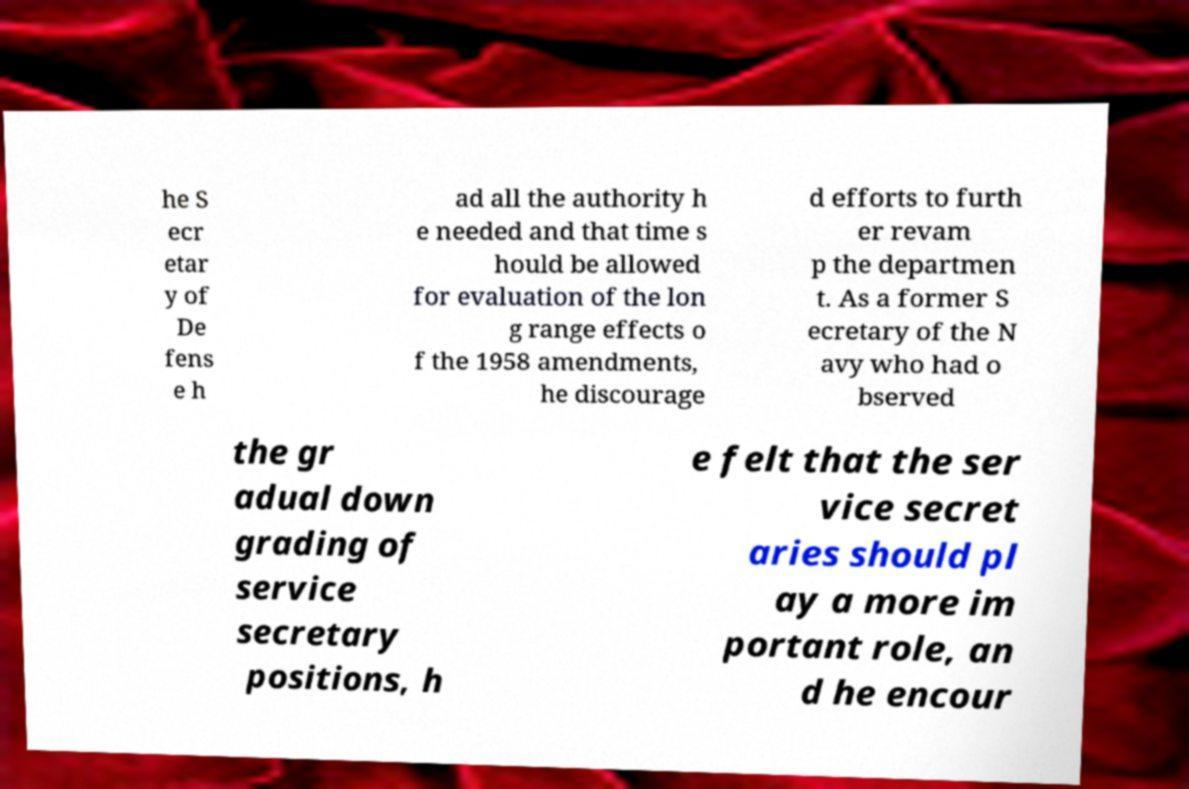For documentation purposes, I need the text within this image transcribed. Could you provide that? he S ecr etar y of De fens e h ad all the authority h e needed and that time s hould be allowed for evaluation of the lon g range effects o f the 1958 amendments, he discourage d efforts to furth er revam p the departmen t. As a former S ecretary of the N avy who had o bserved the gr adual down grading of service secretary positions, h e felt that the ser vice secret aries should pl ay a more im portant role, an d he encour 